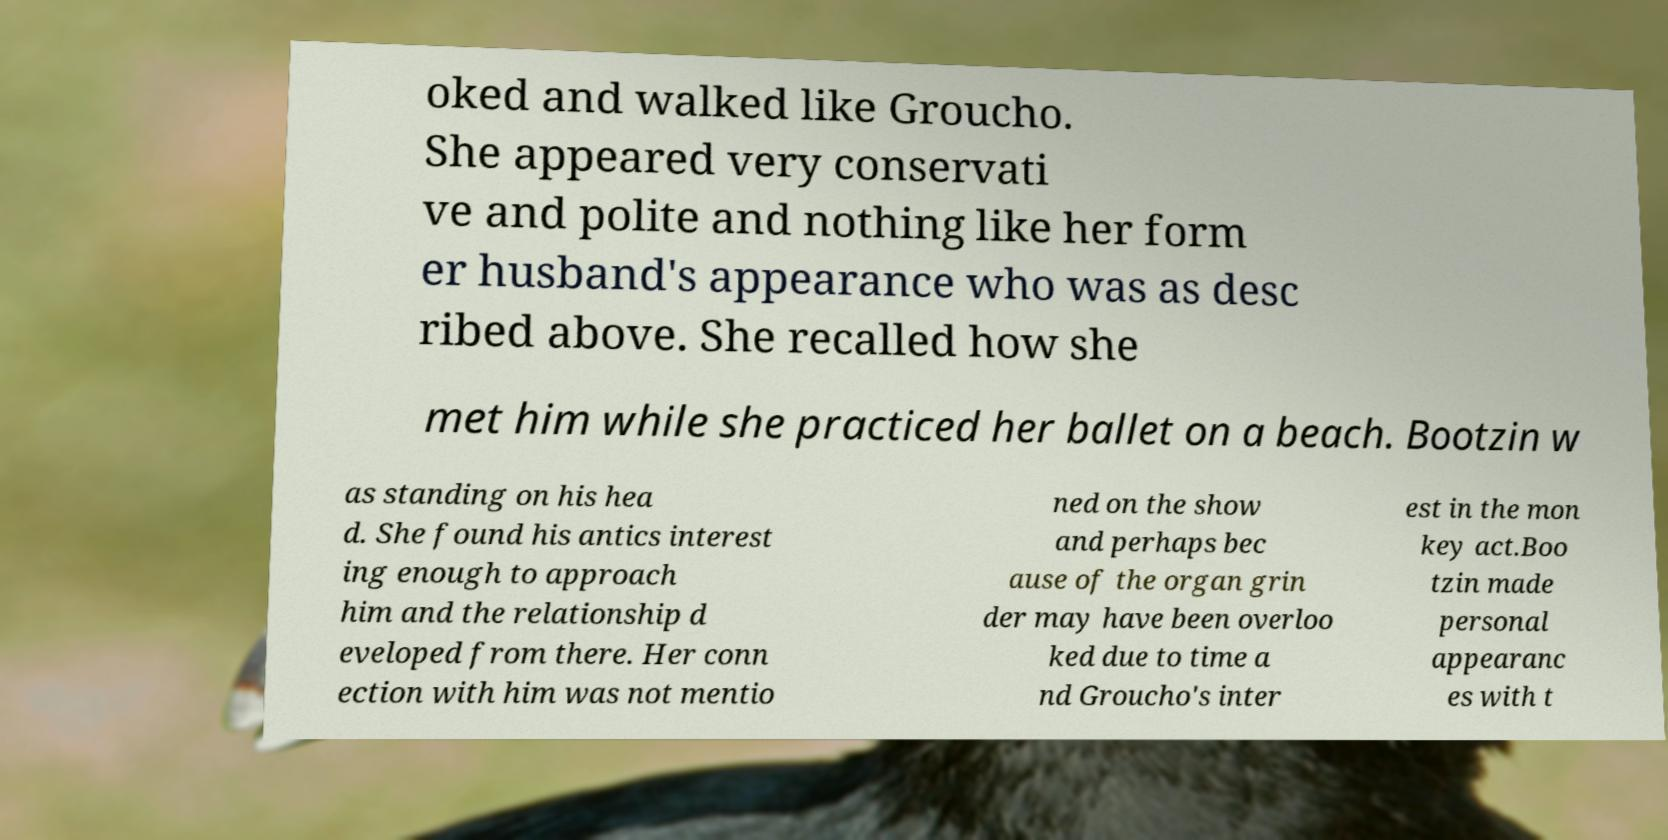Please identify and transcribe the text found in this image. oked and walked like Groucho. She appeared very conservati ve and polite and nothing like her form er husband's appearance who was as desc ribed above. She recalled how she met him while she practiced her ballet on a beach. Bootzin w as standing on his hea d. She found his antics interest ing enough to approach him and the relationship d eveloped from there. Her conn ection with him was not mentio ned on the show and perhaps bec ause of the organ grin der may have been overloo ked due to time a nd Groucho's inter est in the mon key act.Boo tzin made personal appearanc es with t 